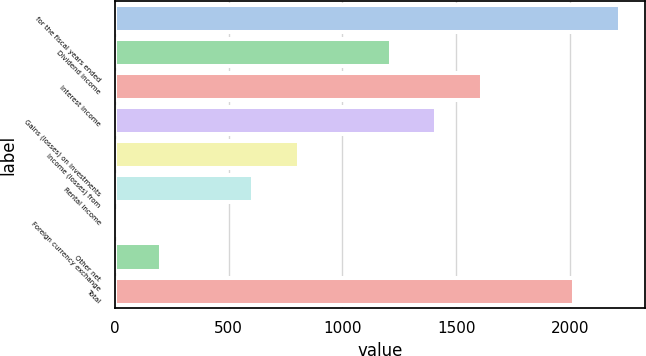Convert chart to OTSL. <chart><loc_0><loc_0><loc_500><loc_500><bar_chart><fcel>for the fiscal years ended<fcel>Dividend income<fcel>Interest income<fcel>Gains (losses) on investments<fcel>Income (losses) from<fcel>Rental income<fcel>Foreign currency exchange<fcel>Other net<fcel>Total<nl><fcel>2219.74<fcel>1211.04<fcel>1614.52<fcel>1412.78<fcel>807.56<fcel>605.82<fcel>0.6<fcel>202.34<fcel>2018<nl></chart> 